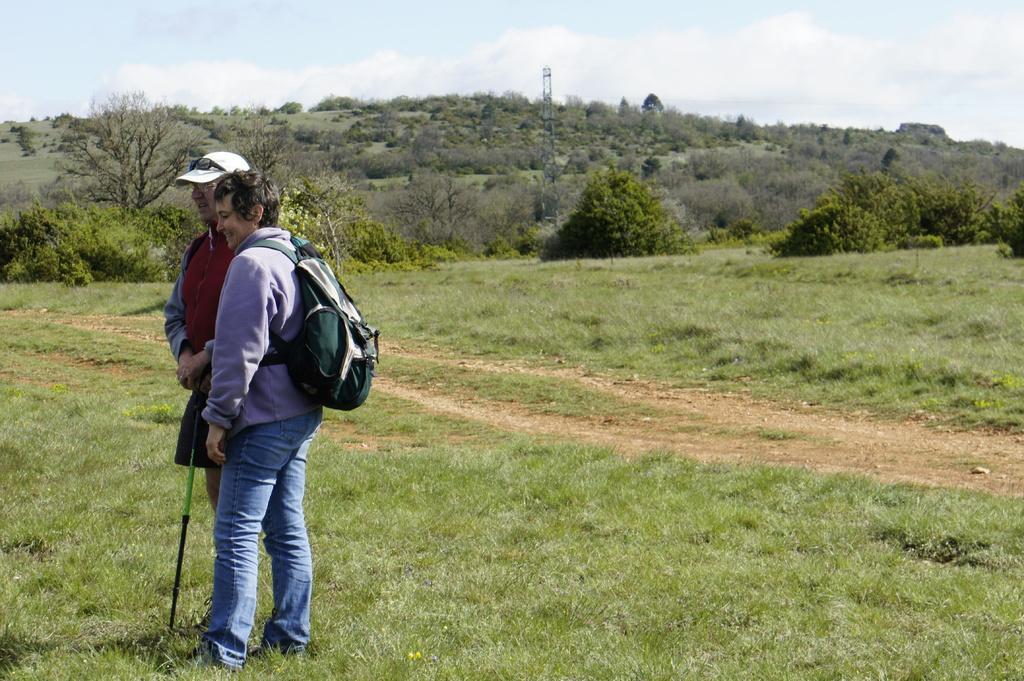Could you give a brief overview of what you see in this image? In this image I can see a man and a woman are standing. The man is wearing a cap and the woman is carrying a bag. In the background I can see trees, the grass, a tower and the sky. 